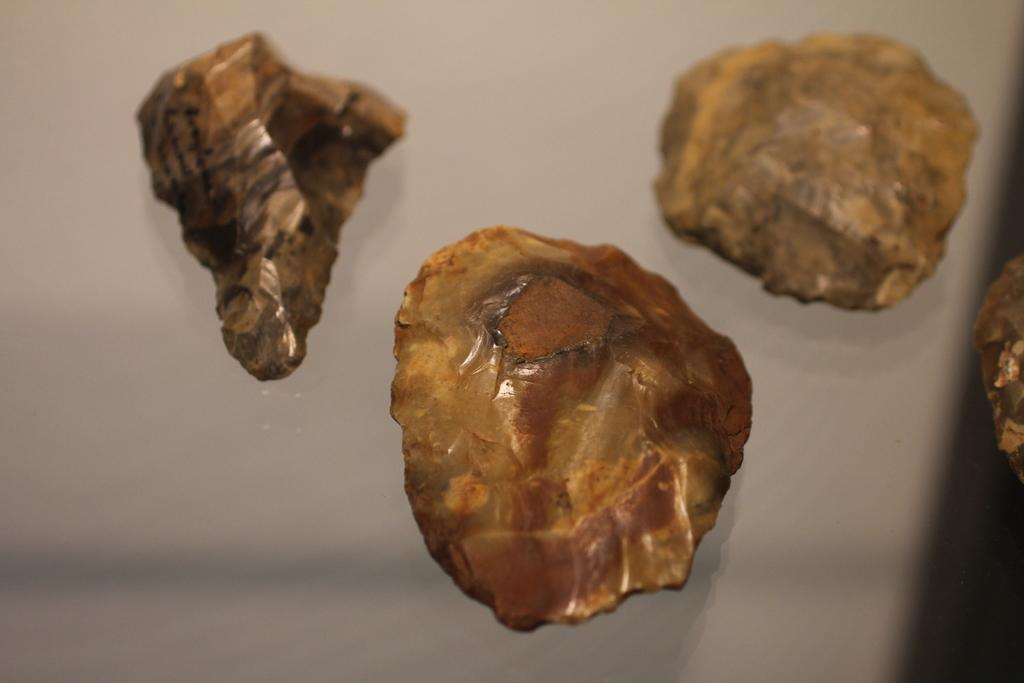How many stones can be seen in the image? There are four stones in the image. Where are the stones located? The stones are on a platform. What type of dinosaur can be seen in the image? There are no dinosaurs present in the image; it features four stones on a platform. How many coughs can be heard in the image? There are no sounds, including coughs, present in the image. 